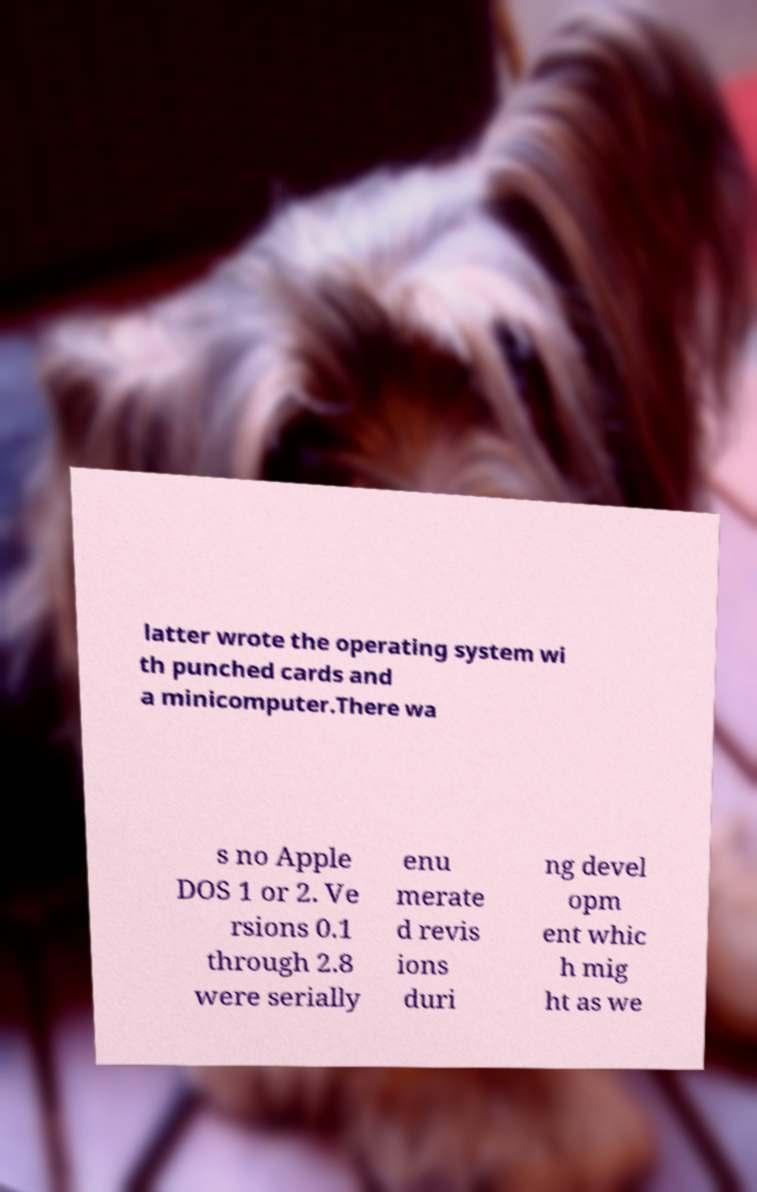I need the written content from this picture converted into text. Can you do that? latter wrote the operating system wi th punched cards and a minicomputer.There wa s no Apple DOS 1 or 2. Ve rsions 0.1 through 2.8 were serially enu merate d revis ions duri ng devel opm ent whic h mig ht as we 